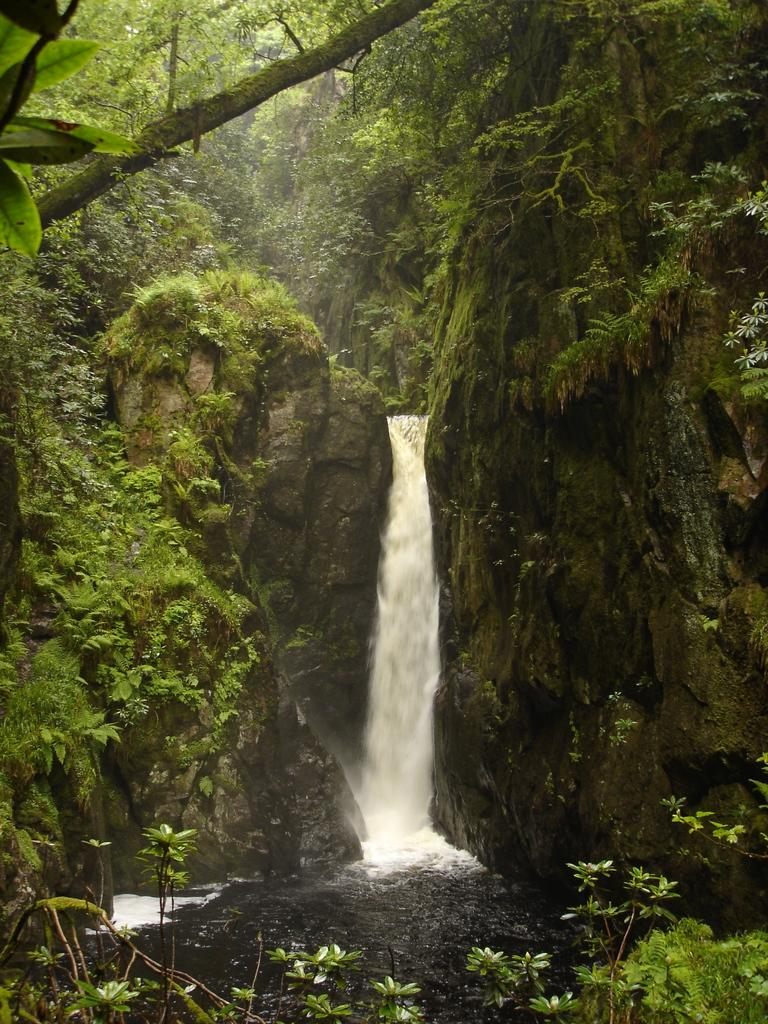What natural feature is the main subject of the image? There is a waterfall in the image. What other elements can be seen in the image? There are plants, algae, a branch, a hill, and leaves visible in the image. What type of pie is being served on a spoon in the image? There is no pie or spoon present in the image; it features a waterfall, plants, algae, a branch, a hill, and leaves. 